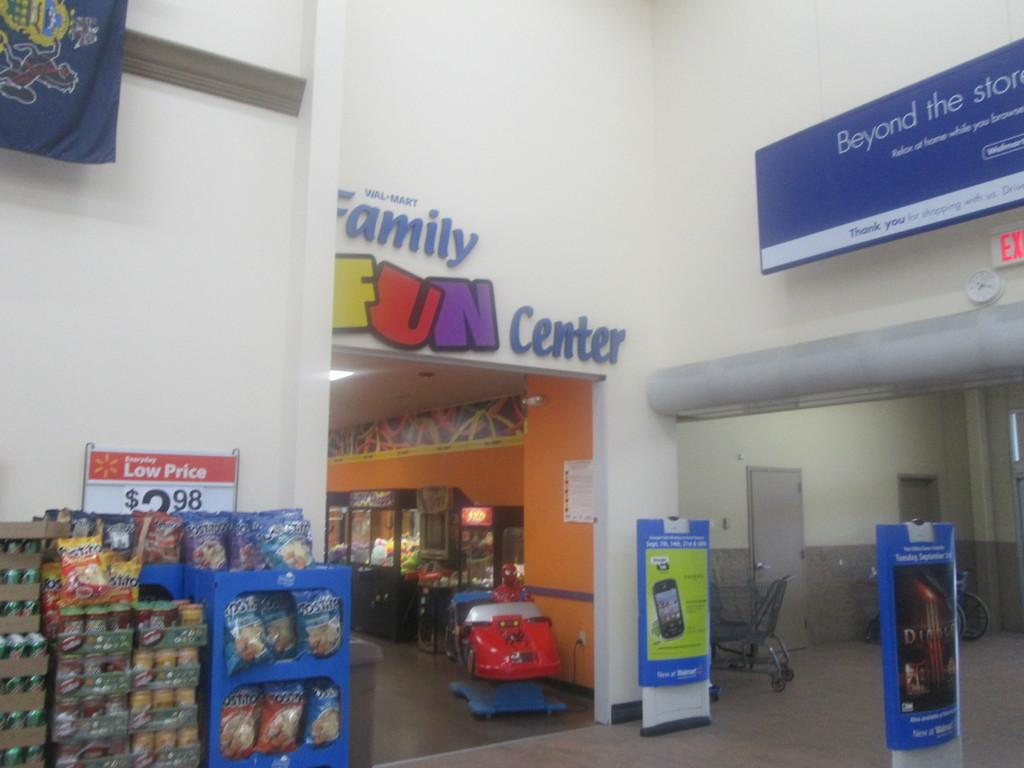What type of establishment is depicted in the image? There is a store in the image. What can be found inside the store? There are packets in the store. What is visible in the background of the image? There is a wall in the background of the image. What is written or displayed on the wall in the background? There is text on the wall in the background. Is there any snow visible in the image? No, there is no snow present in the image. 